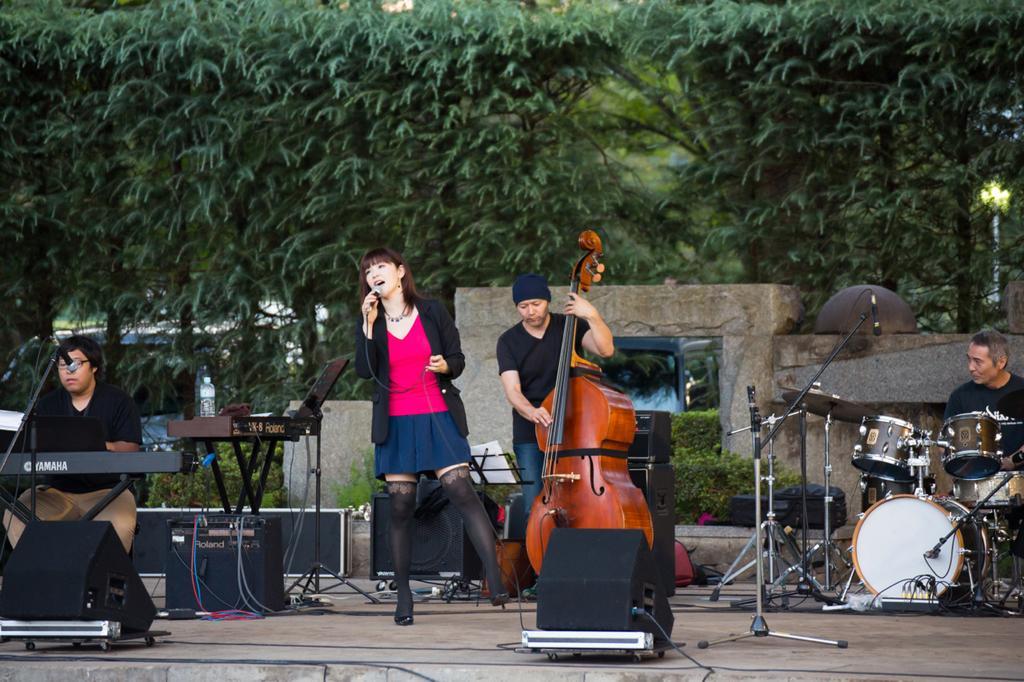How would you summarize this image in a sentence or two? In this picture we can see four people on stage where three are playing musical instruments and a woman singing on mic, speakers, stands and in the background we can see trees. 